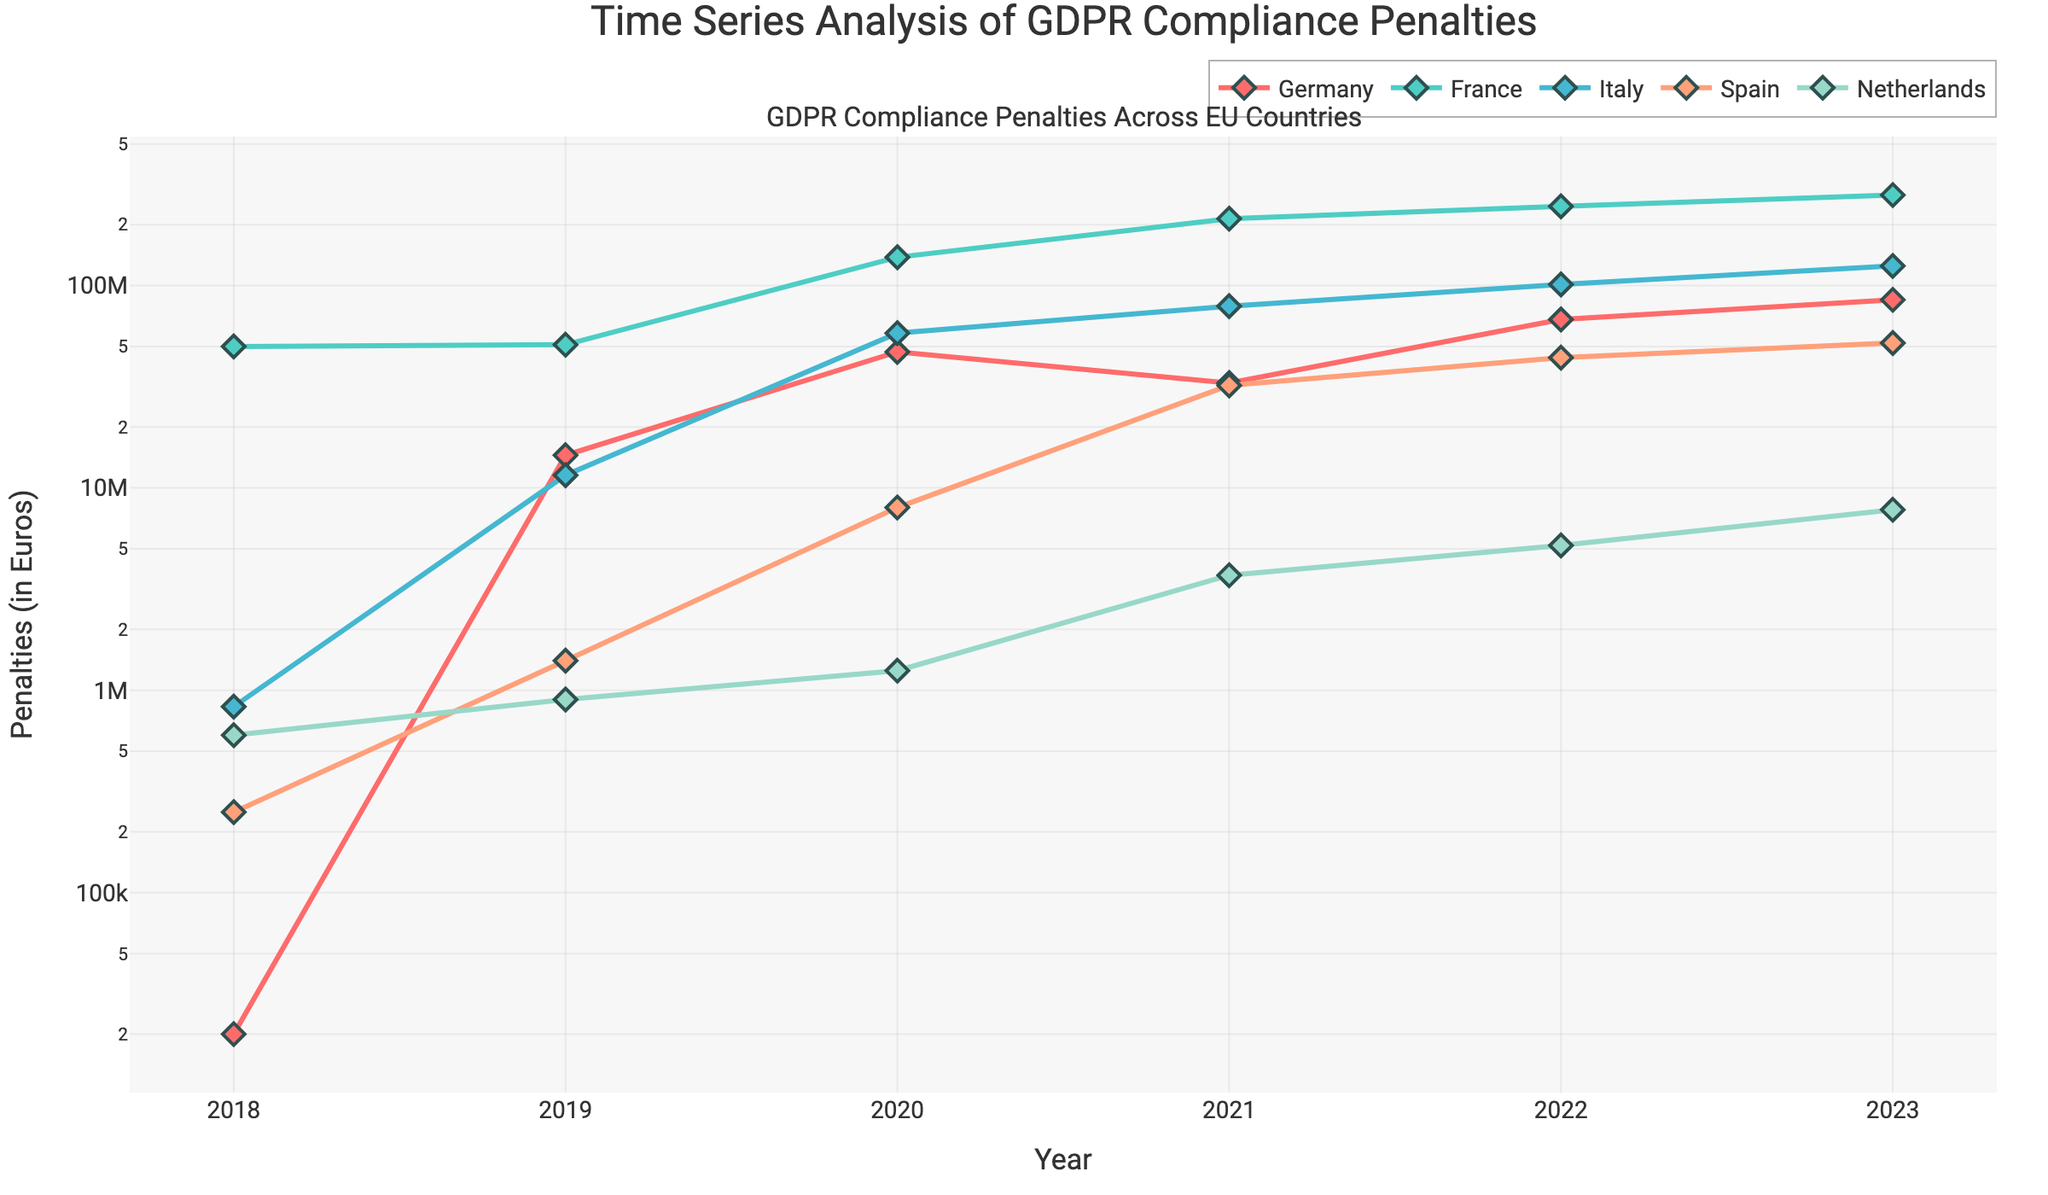What was the penalty amount for Germany in 2023? To determine the penalty amount for Germany in 2023, find the data point on the line representing Germany and read the value for the year 2023.
Answer: 85,000,000 How did the penalties for France change from 2018 to 2023? Subtract the penalty amount for France in 2018 from the amount in 2023 to get the difference. France's penalties in 2018 were 50,000,000 and in 2023 were 280,000,000. The change is 280,000,000 - 50,000,000.
Answer: 230,000,000 Which country had the highest GDPR penalty in 2020? Find the data points for all the countries in the year 2020 and identify the maximum value. France's penalty amount in 2020 was 138,000,000, the highest among the countries listed.
Answer: France What was Italy's total penalty amount from 2018 to 2023? Sum the penalty amounts for Italy from 2018 to 2023: 830,000 + 11,550,000 + 58,160,000 + 79,100,000 + 101,200,000 + 125,000,000.
Answer: 375,840,000 In which year did Spain see the greatest increase in penalties from the previous year? Calculate the year-over-year differences for Spain and identify the greatest one: (2019-2018: 1,400,000 - 250,000 = 1,150,000), (2020-2019: 8,000,000 - 1,400,000 = 6,600,000), (2021-2020: 32,100,000 - 8,000,000 = 24,100,000), (2022-2021: 44,000,000 - 32,100,000 = 11,900,000), (2023-2022: 52,000,000 - 44,000,000 = 8,000,000). The greatest increase was from 2020 to 2021.
Answer: 2021 Compare the penalties for Italy and the Netherlands in 2022. Which country had higher penalties? Identify the penalty amounts for Italy and the Netherlands in 2022 and compare them: Italy had 101,200,000 and the Netherlands had 5,200,000. Italy had the higher penalty.
Answer: Italy What was the average penalty amount for Spain from 2018 to 2023? Find the penalty amounts for Spain from 2018 to 2023, sum them, and divide by the number of years: (250,000 + 1,400,000 + 8,000,000 + 32,100,000 + 44,000,000 + 52,000,000) / 6.
Answer: 22,625,000 